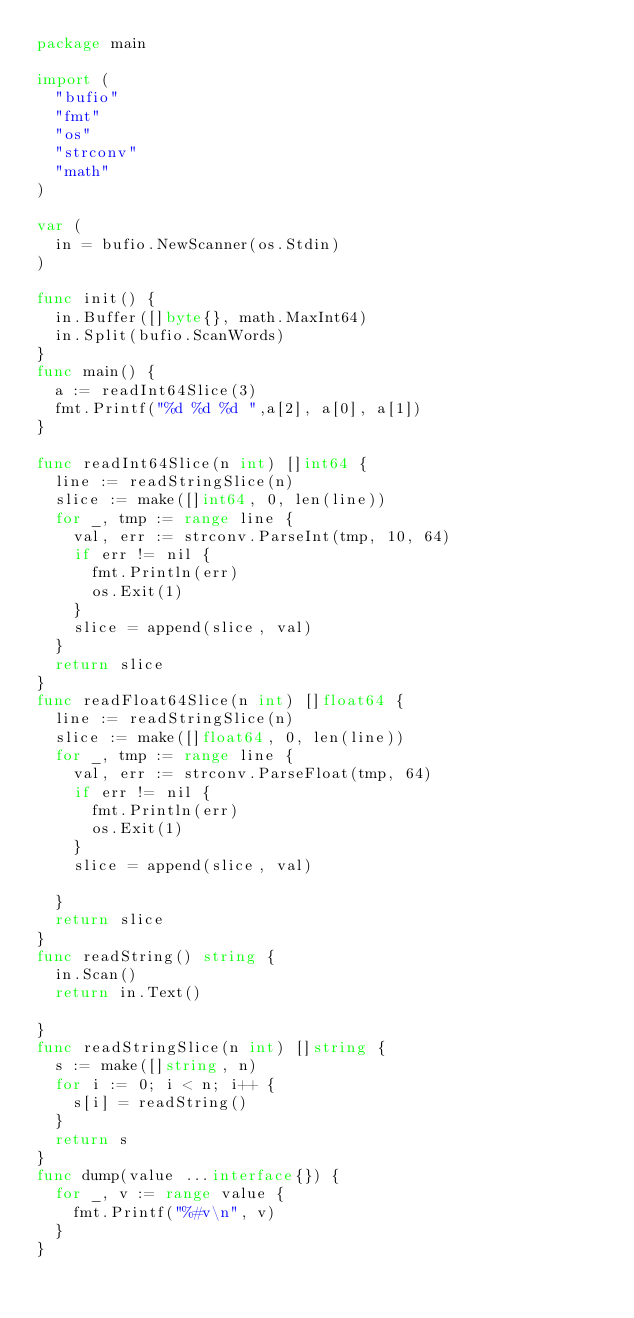<code> <loc_0><loc_0><loc_500><loc_500><_Go_>package main

import (
	"bufio"
	"fmt"
	"os"
	"strconv"
	"math"
)

var (
	in = bufio.NewScanner(os.Stdin)
)

func init() {
	in.Buffer([]byte{}, math.MaxInt64)
	in.Split(bufio.ScanWords)
}
func main() {
	a := readInt64Slice(3)
	fmt.Printf("%d %d %d ",a[2], a[0], a[1])
}

func readInt64Slice(n int) []int64 {
	line := readStringSlice(n)
	slice := make([]int64, 0, len(line))
	for _, tmp := range line {
		val, err := strconv.ParseInt(tmp, 10, 64)
		if err != nil {
			fmt.Println(err)
			os.Exit(1)
		}
		slice = append(slice, val)
	}
	return slice
}
func readFloat64Slice(n int) []float64 {
	line := readStringSlice(n)
	slice := make([]float64, 0, len(line))
	for _, tmp := range line {
		val, err := strconv.ParseFloat(tmp, 64)
		if err != nil {
			fmt.Println(err)
			os.Exit(1)
		}
		slice = append(slice, val)

	}
	return slice
}
func readString() string {
	in.Scan()
	return in.Text()

}
func readStringSlice(n int) []string {
	s := make([]string, n)
	for i := 0; i < n; i++ {
		s[i] = readString()
	}
	return s
}
func dump(value ...interface{}) {
	for _, v := range value {
		fmt.Printf("%#v\n", v)
	}
}</code> 